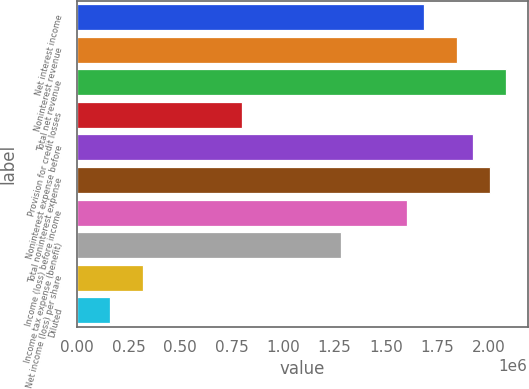Convert chart. <chart><loc_0><loc_0><loc_500><loc_500><bar_chart><fcel>Net interest income<fcel>Noninterest revenue<fcel>Total net revenue<fcel>Provision for credit losses<fcel>Noninterest expense before<fcel>Total noninterest expense<fcel>Income (loss) before income<fcel>Income tax expense (benefit)<fcel>Net income (loss) per share<fcel>Diluted<nl><fcel>1.68226e+06<fcel>1.84248e+06<fcel>2.0828e+06<fcel>801078<fcel>1.92259e+06<fcel>2.00269e+06<fcel>1.60216e+06<fcel>1.28172e+06<fcel>320431<fcel>160216<nl></chart> 